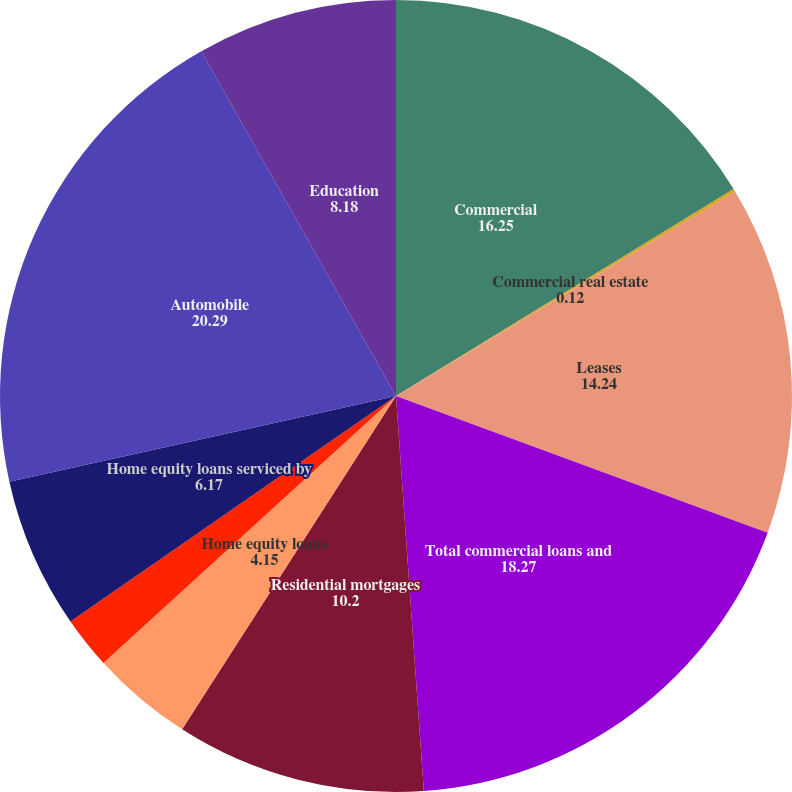Convert chart to OTSL. <chart><loc_0><loc_0><loc_500><loc_500><pie_chart><fcel>Commercial<fcel>Commercial real estate<fcel>Leases<fcel>Total commercial loans and<fcel>Residential mortgages<fcel>Home equity loans<fcel>Home equity lines of credit<fcel>Home equity loans serviced by<fcel>Automobile<fcel>Education<nl><fcel>16.25%<fcel>0.12%<fcel>14.24%<fcel>18.27%<fcel>10.2%<fcel>4.15%<fcel>2.13%<fcel>6.17%<fcel>20.29%<fcel>8.18%<nl></chart> 